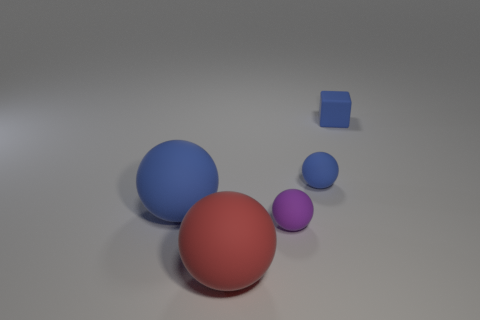What number of tiny purple matte objects are there? There is one small purple matte object in the image. It appears on the right side, distinct in its color and size compared to the other objects present. 